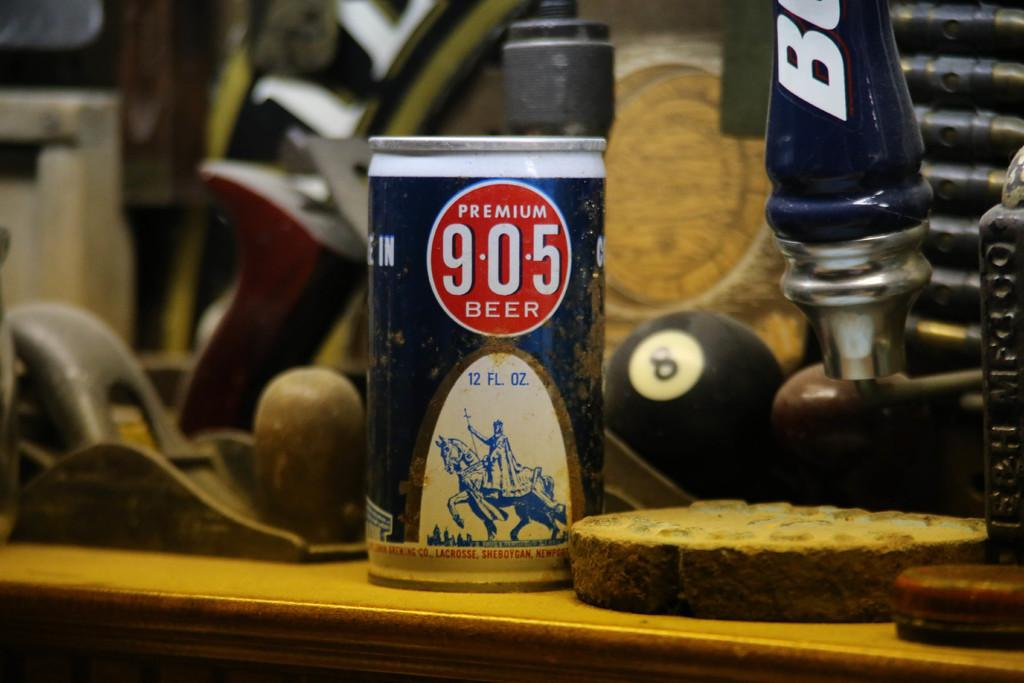What is the main subject of the image? The main subject of the image is a group of objects on a table. Can you describe one of the objects in the foreground? There is a tin in the foreground of the image. What can be seen on the tin? The tin has a label on it. What information is present on the label? The label contains text and an image. What type of arithmetic problem is solved on the tin's label in the image? There is no arithmetic problem present on the tin's label in the image. What material is the tin made of in the image? The material of the tin is not mentioned in the provided facts, so it cannot be determined from the image. 